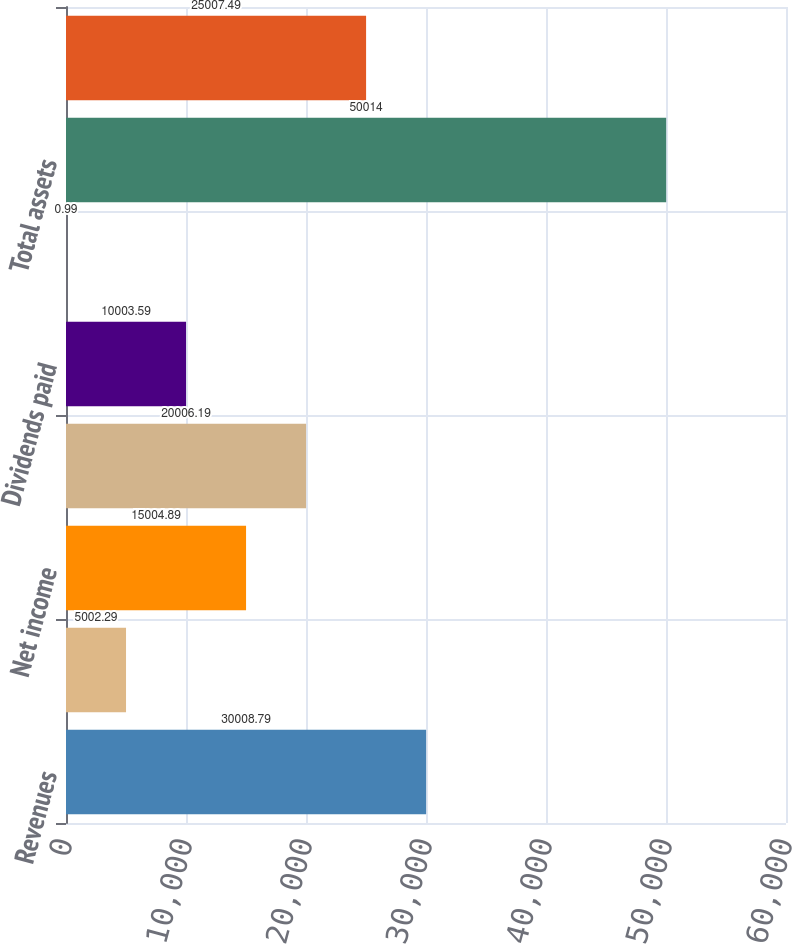<chart> <loc_0><loc_0><loc_500><loc_500><bar_chart><fcel>Revenues<fcel>Income from continuing<fcel>Net income<fcel>Additions to property plant<fcel>Dividends paid<fcel>Dividends per share<fcel>Total assets<fcel>Total long-term debt including<nl><fcel>30008.8<fcel>5002.29<fcel>15004.9<fcel>20006.2<fcel>10003.6<fcel>0.99<fcel>50014<fcel>25007.5<nl></chart> 